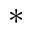<formula> <loc_0><loc_0><loc_500><loc_500>^ { \ast }</formula> 